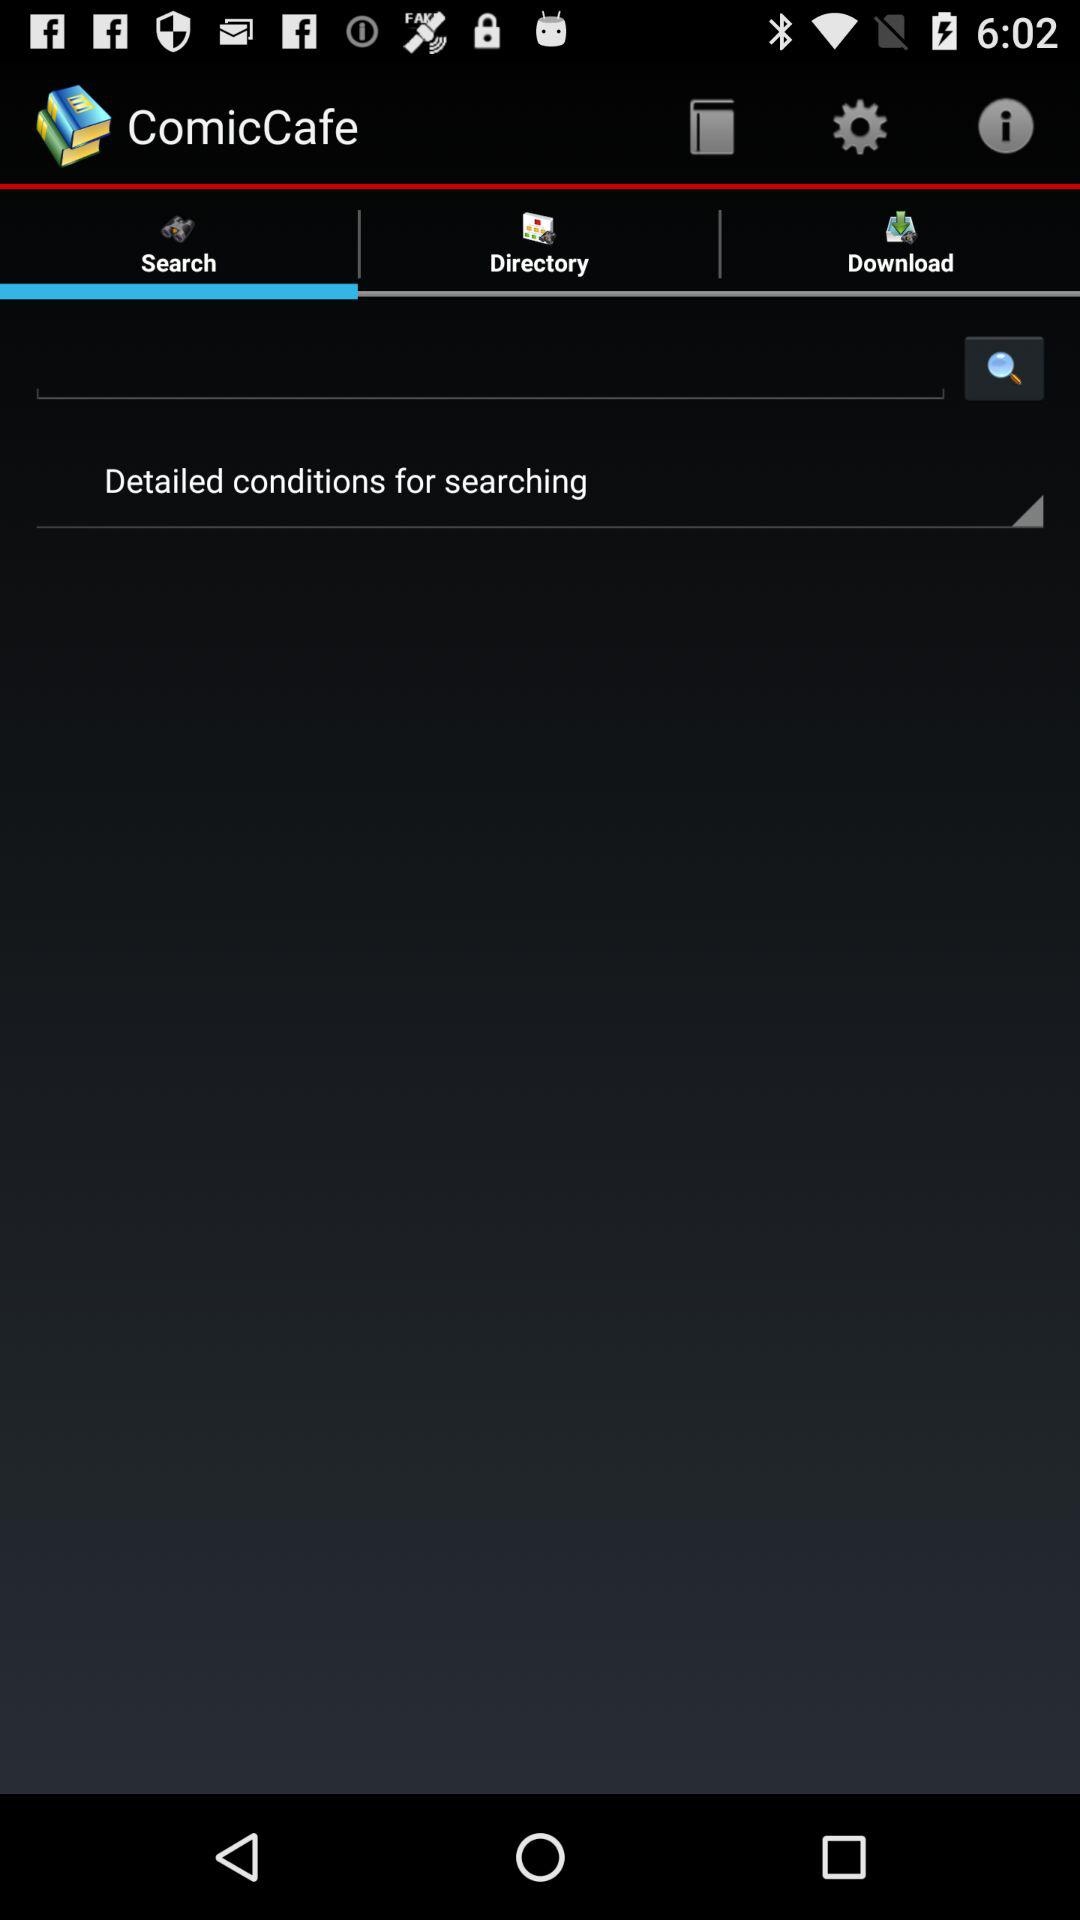When was the last search?
When the provided information is insufficient, respond with <no answer>. <no answer> 